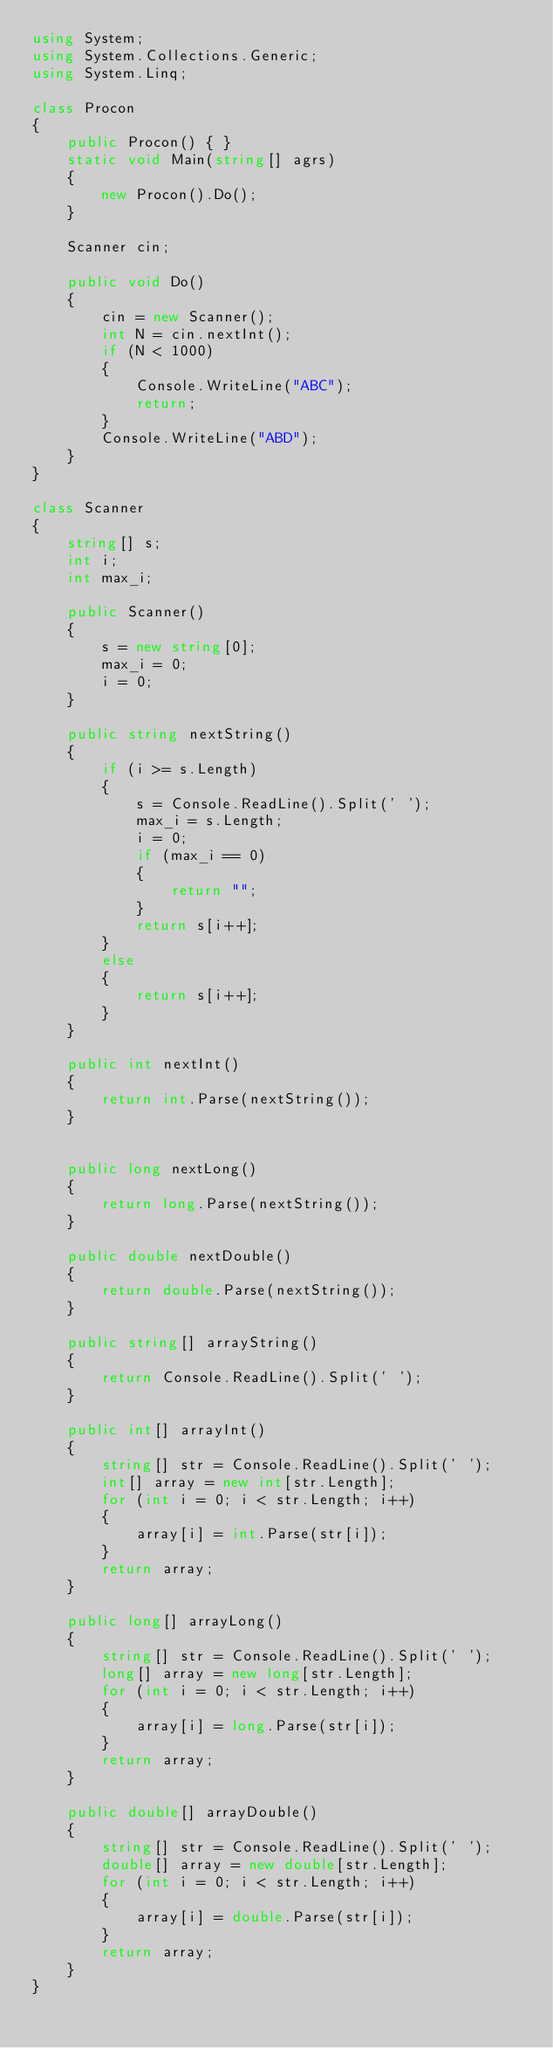Convert code to text. <code><loc_0><loc_0><loc_500><loc_500><_C#_>using System;
using System.Collections.Generic;
using System.Linq;

class Procon
{
    public Procon() { }
    static void Main(string[] agrs)
    {
        new Procon().Do();
    }

    Scanner cin;

    public void Do()
    {
        cin = new Scanner();
        int N = cin.nextInt();
        if (N < 1000)
        {
            Console.WriteLine("ABC");
            return;
        }
        Console.WriteLine("ABD");
    }
}

class Scanner
{
    string[] s;
    int i;
    int max_i;

    public Scanner()
    {
        s = new string[0];
        max_i = 0;
        i = 0;
    }

    public string nextString()
    {
        if (i >= s.Length)
        {
            s = Console.ReadLine().Split(' ');
            max_i = s.Length;
            i = 0;
            if (max_i == 0)
            {
                return "";
            }
            return s[i++];
        }
        else
        {
            return s[i++];
        }
    }

    public int nextInt()
    {
        return int.Parse(nextString());
    }


    public long nextLong()
    {
        return long.Parse(nextString());
    }

    public double nextDouble()
    {
        return double.Parse(nextString());
    }

    public string[] arrayString()
    {
        return Console.ReadLine().Split(' ');
    }

    public int[] arrayInt()
    {
        string[] str = Console.ReadLine().Split(' ');
        int[] array = new int[str.Length];
        for (int i = 0; i < str.Length; i++)
        {
            array[i] = int.Parse(str[i]);
        }
        return array;
    }

    public long[] arrayLong()
    {
        string[] str = Console.ReadLine().Split(' ');
        long[] array = new long[str.Length];
        for (int i = 0; i < str.Length; i++)
        {
            array[i] = long.Parse(str[i]);
        }
        return array;
    }

    public double[] arrayDouble()
    {
        string[] str = Console.ReadLine().Split(' ');
        double[] array = new double[str.Length];
        for (int i = 0; i < str.Length; i++)
        {
            array[i] = double.Parse(str[i]);
        }
        return array;
    }
}</code> 